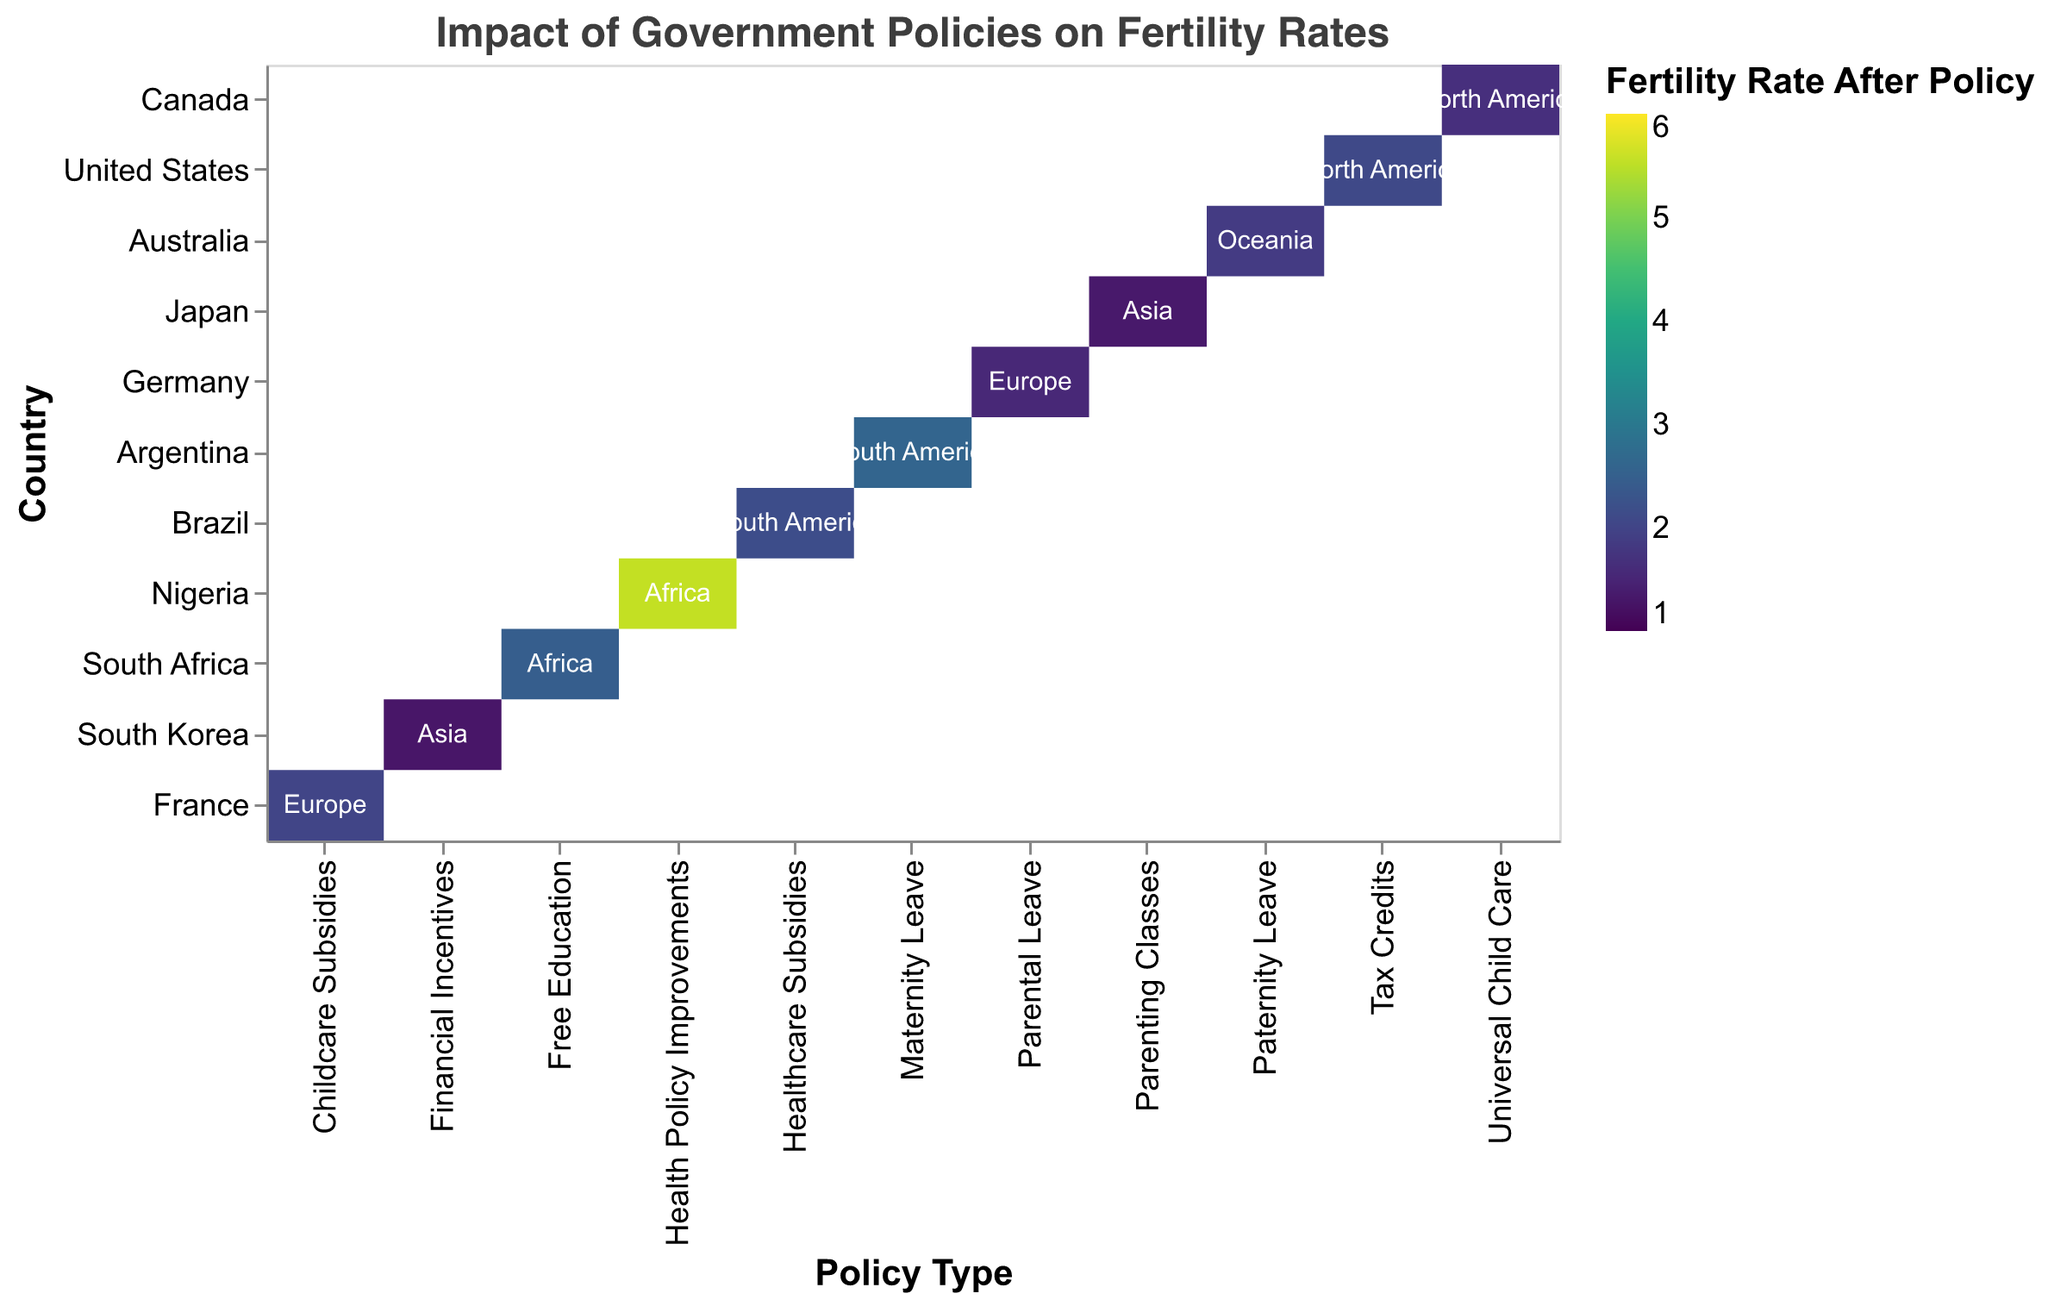What is the title of the heatmap? The heatmap's title is displayed at the top and reads "Impact of Government Policies on Fertility Rates."
Answer: Impact of Government Policies on Fertility Rates Which continent has the highest fertility rate after policy implementation, according to the heatmap? By identifying the highest color intensity in the scale (viridis) and checking the corresponding text labels, we can see that Nigeria in Africa has the highest fertility rate after policy implementation, which is 5.55.
Answer: Africa What is the fertility rate in Germany after implementing Parental Leave policies? Locate Germany on the y-axis and look at the corresponding cell under the "Parental Leave" policy type on the x-axis. The color intensity and legend show that the fertility rate after implementation is 1.55.
Answer: 1.55 Which country shows a decrease in fertility rate after policy implementation in North America? Observe the color differences, and by referring to the data, we can note the countries in North America. The United States shows a slight decrease from 2.10 to 2.08 after implementing Tax Credits.
Answer: United States How many countries in South America are included in the heatmap, and what are their fertility rates after policy implementation? Read the labels on the y-axis for countries in South America. Brazil and Argentina are included. Brazil's fertility rate is 2.15, and Argentina's is 2.60 after policy implementation.
Answer: Two countries: Brazil (2.15) and Argentina (2.60) Compare the effectiveness of parenting-related policies (Parental Leave, Parenting Classes) in Germany and Japan. Which country had a greater increase in fertility rate? Locate Germany and Japan on the y-axis. For Germany (Parental Leave), the change is from 1.40 to 1.55 (increase of 0.15). For Japan (Parenting Classes), the change is from 1.25 to 1.32 (increase of 0.07). Therefore, Germany had a greater increase.
Answer: Germany Which continent has the most diverse policy types represented in the heatmap? Identify the continents and count the unique policy types for each in the heatmap. Europe has the highest diversity with both Parental Leave and Childcare Subsidies.
Answer: Europe What is the average fertility rate after policy implementation for countries in Africa? Locate African countries (South Africa and Nigeria), sum their fertility rates after policy (2.47 and 5.55 respectively), and divide by the number of countries. Thus, (2.47 + 5.55) / 2 = 4.01.
Answer: 4.01 Which country in Asia has shown a greater increase in fertility rate after policy implementation, Japan or South Korea? Japan's increment is from 1.25 to 1.32 (0.07), and South Korea's increment is from 1.20 to 1.28 (0.08). Thus, South Korea has shown a greater increase.
Answer: South Korea What is the policy type associated with the highest and the lowest fertility rates in the heatmap? Identify the policy types associated with the cells of highest and lowest color intensity according to the legend. The highest fertility rate corresponds to Nigeria with Health Policy Improvements (5.55), and the lowest to Japan with Parenting Classes (1.32).
Answer: Highest: Health Policy Improvements; Lowest: Parenting Classes 